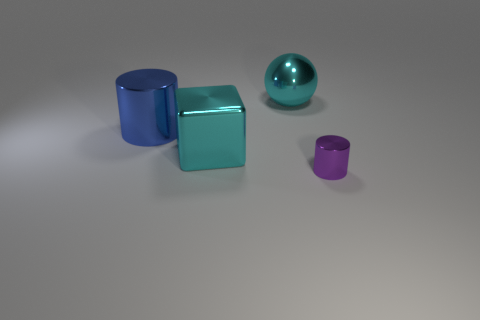Add 4 small purple metal cylinders. How many objects exist? 8 Subtract all cubes. How many objects are left? 3 Subtract all big cyan things. Subtract all metal cylinders. How many objects are left? 0 Add 3 cyan metal objects. How many cyan metal objects are left? 5 Add 2 green rubber balls. How many green rubber balls exist? 2 Subtract 0 green cylinders. How many objects are left? 4 